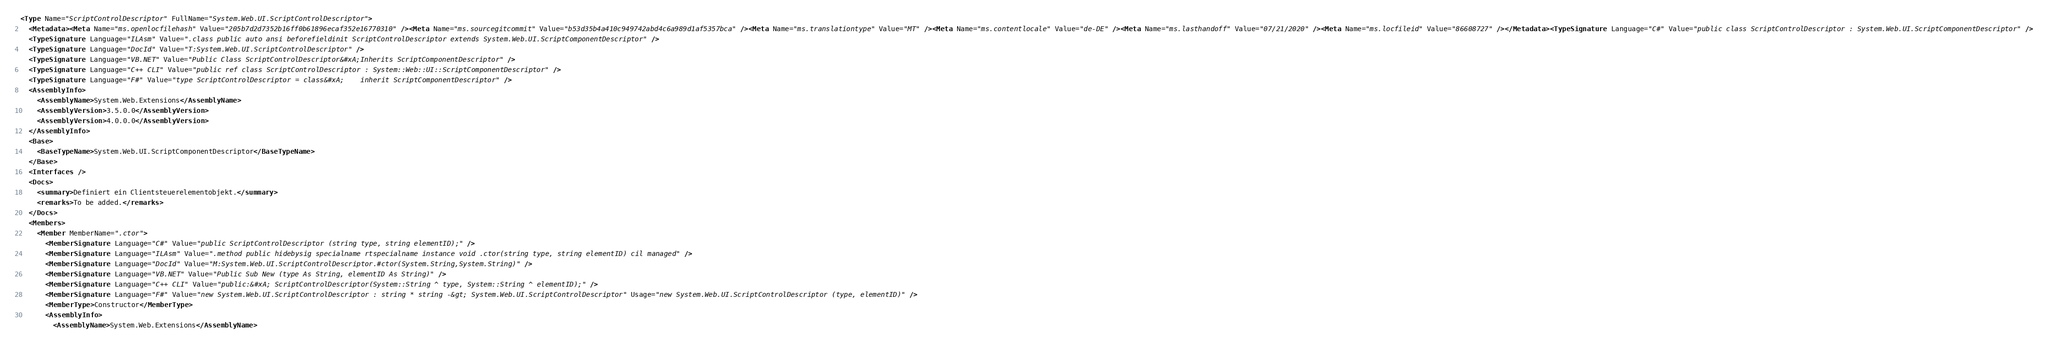Convert code to text. <code><loc_0><loc_0><loc_500><loc_500><_XML_><Type Name="ScriptControlDescriptor" FullName="System.Web.UI.ScriptControlDescriptor">
  <Metadata><Meta Name="ms.openlocfilehash" Value="205b7d2d7352b16ff0b61896ecaf352e16770310" /><Meta Name="ms.sourcegitcommit" Value="b53d35b4a410c949742abd4c6a989d1af5357bca" /><Meta Name="ms.translationtype" Value="MT" /><Meta Name="ms.contentlocale" Value="de-DE" /><Meta Name="ms.lasthandoff" Value="07/21/2020" /><Meta Name="ms.locfileid" Value="86608727" /></Metadata><TypeSignature Language="C#" Value="public class ScriptControlDescriptor : System.Web.UI.ScriptComponentDescriptor" />
  <TypeSignature Language="ILAsm" Value=".class public auto ansi beforefieldinit ScriptControlDescriptor extends System.Web.UI.ScriptComponentDescriptor" />
  <TypeSignature Language="DocId" Value="T:System.Web.UI.ScriptControlDescriptor" />
  <TypeSignature Language="VB.NET" Value="Public Class ScriptControlDescriptor&#xA;Inherits ScriptComponentDescriptor" />
  <TypeSignature Language="C++ CLI" Value="public ref class ScriptControlDescriptor : System::Web::UI::ScriptComponentDescriptor" />
  <TypeSignature Language="F#" Value="type ScriptControlDescriptor = class&#xA;    inherit ScriptComponentDescriptor" />
  <AssemblyInfo>
    <AssemblyName>System.Web.Extensions</AssemblyName>
    <AssemblyVersion>3.5.0.0</AssemblyVersion>
    <AssemblyVersion>4.0.0.0</AssemblyVersion>
  </AssemblyInfo>
  <Base>
    <BaseTypeName>System.Web.UI.ScriptComponentDescriptor</BaseTypeName>
  </Base>
  <Interfaces />
  <Docs>
    <summary>Definiert ein Clientsteuerelementobjekt.</summary>
    <remarks>To be added.</remarks>
  </Docs>
  <Members>
    <Member MemberName=".ctor">
      <MemberSignature Language="C#" Value="public ScriptControlDescriptor (string type, string elementID);" />
      <MemberSignature Language="ILAsm" Value=".method public hidebysig specialname rtspecialname instance void .ctor(string type, string elementID) cil managed" />
      <MemberSignature Language="DocId" Value="M:System.Web.UI.ScriptControlDescriptor.#ctor(System.String,System.String)" />
      <MemberSignature Language="VB.NET" Value="Public Sub New (type As String, elementID As String)" />
      <MemberSignature Language="C++ CLI" Value="public:&#xA; ScriptControlDescriptor(System::String ^ type, System::String ^ elementID);" />
      <MemberSignature Language="F#" Value="new System.Web.UI.ScriptControlDescriptor : string * string -&gt; System.Web.UI.ScriptControlDescriptor" Usage="new System.Web.UI.ScriptControlDescriptor (type, elementID)" />
      <MemberType>Constructor</MemberType>
      <AssemblyInfo>
        <AssemblyName>System.Web.Extensions</AssemblyName></code> 